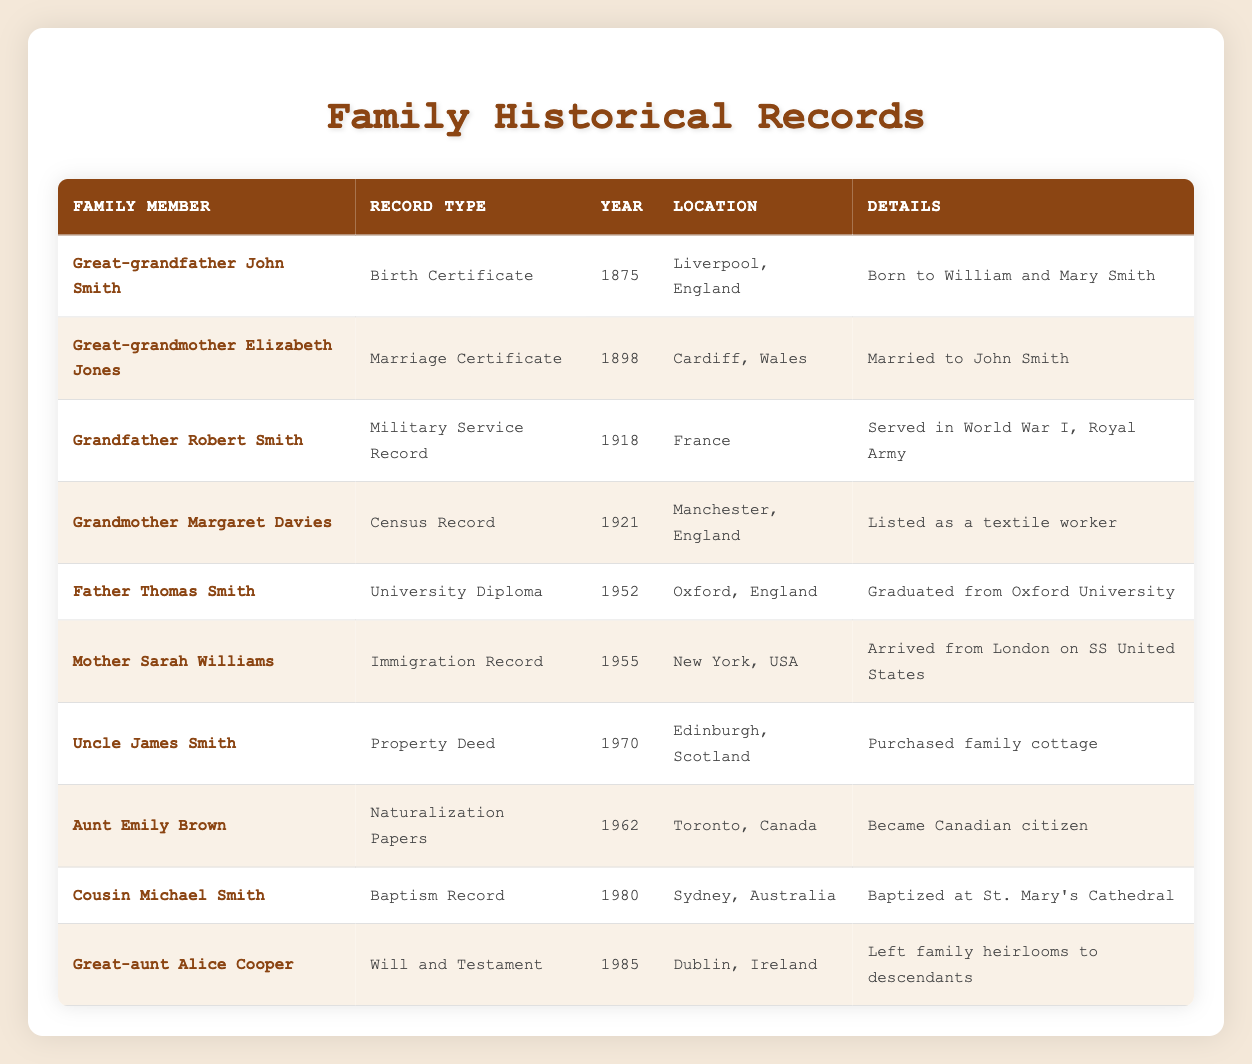What is the record type for Great-grandfather John Smith? The table lists the record type for Great-grandfather John Smith as "Birth Certificate." This can be directly found in the corresponding row for him.
Answer: Birth Certificate In what year was Great-grandmother Elizabeth Jones married? The table indicates that Great-grandmother Elizabeth Jones was married in the year 1898. This information is included in her specific row in the table.
Answer: 1898 How many family members have records related to the year 1980? In the table, there is one family member, Cousin Michael Smith, who has a record from the year 1980. This can be confirmed by finding the specific entry for that year and counting the relevant rows.
Answer: 1 Did Grandfather Robert Smith serve in World War I? Yes, the table explicitly states that Grandfather Robert Smith's record type is "Military Service Record," and he served in World War I, according to the details provided in his row.
Answer: Yes Which family member has a record related to a marriage? The table shows that Great-grandmother Elizabeth Jones has a "Marriage Certificate." This information can be retrieved from her corresponding row.
Answer: Great-grandmother Elizabeth Jones How many family members in the table have records from the 20th century (1900-1999)? The table includes several family members with records from the 20th century: Great-grandmother Elizabeth Jones, Grandfather Robert Smith, Grandmother Margaret Davies, Father Thomas Smith, Mother Sarah Williams, Uncle James Smith, Aunt Emily Brown. This gives a total of 7 family members, confirmed by counting the relevant rows.
Answer: 7 What is the significance of Great-aunt Alice Cooper's record? Great-aunt Alice Cooper's record is a "Will and Testament," and it is significant because it states she left family heirlooms to her descendants. This detail can be found in the specific row dedicated to her in the table.
Answer: She left family heirlooms to descendants Which record type appears most frequently among family members in the table? To find the most frequently occurring record type, we can count each type. The three record types for "Certificate," "Record," and "Papers" were repeated several times. However, specific counting would show "Record" appears four times, hence it is the most frequent type.
Answer: Military Service Record Was Cousin Michael Smith baptized in England? No, the table indicates that Cousin Michael Smith was baptized at St. Mary's Cathedral in Sydney, Australia, according to the details found in his row.
Answer: No 